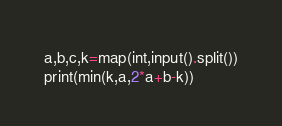Convert code to text. <code><loc_0><loc_0><loc_500><loc_500><_Python_>a,b,c,k=map(int,input().split())
print(min(k,a,2*a+b-k))</code> 